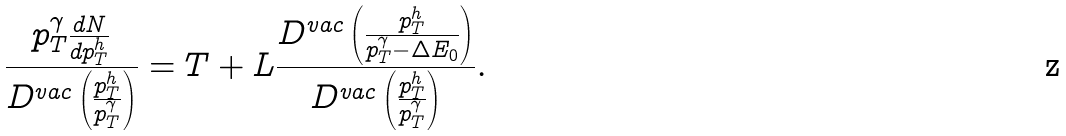Convert formula to latex. <formula><loc_0><loc_0><loc_500><loc_500>\frac { p _ { T } ^ { \gamma } \frac { d N } { d p _ { T } ^ { h } } } { D ^ { v a c } \left ( \frac { p _ { T } ^ { h } } { p _ { T } ^ { \gamma } } \right ) } = T + L \frac { D ^ { v a c } \left ( \frac { p _ { T } ^ { h } } { p _ { T } ^ { \gamma } - \Delta E _ { 0 } } \right ) } { D ^ { v a c } \left ( \frac { p _ { T } ^ { h } } { p _ { T } ^ { \gamma } } \right ) } .</formula> 